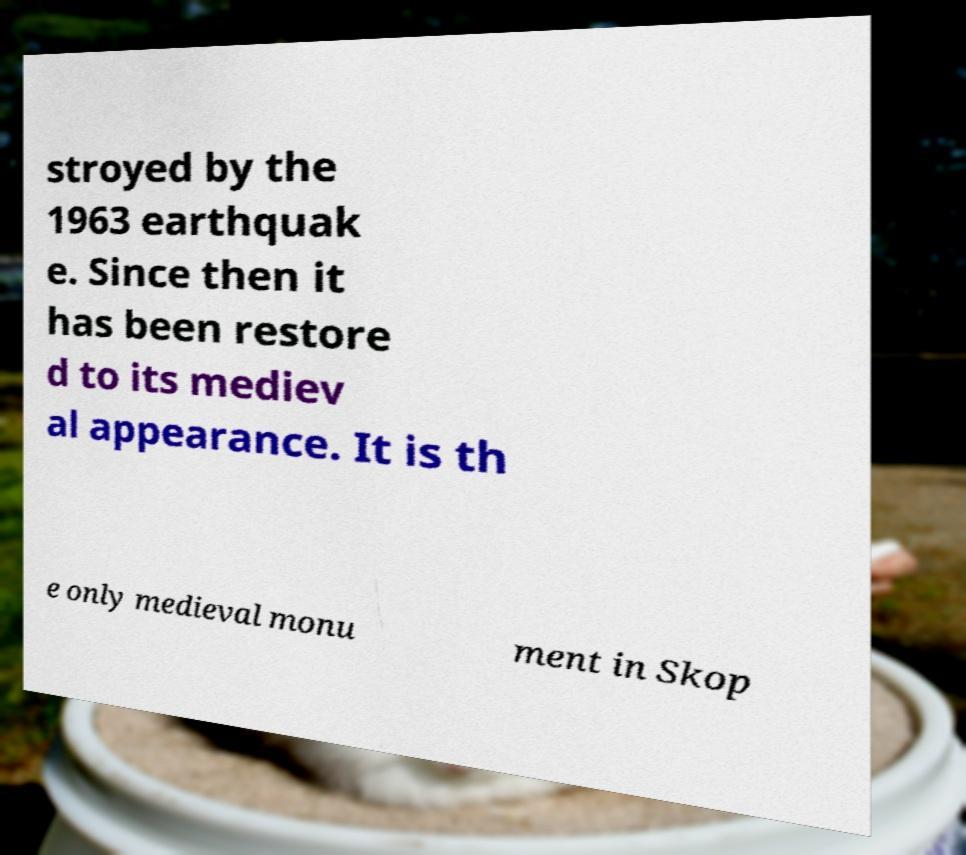What messages or text are displayed in this image? I need them in a readable, typed format. stroyed by the 1963 earthquak e. Since then it has been restore d to its mediev al appearance. It is th e only medieval monu ment in Skop 